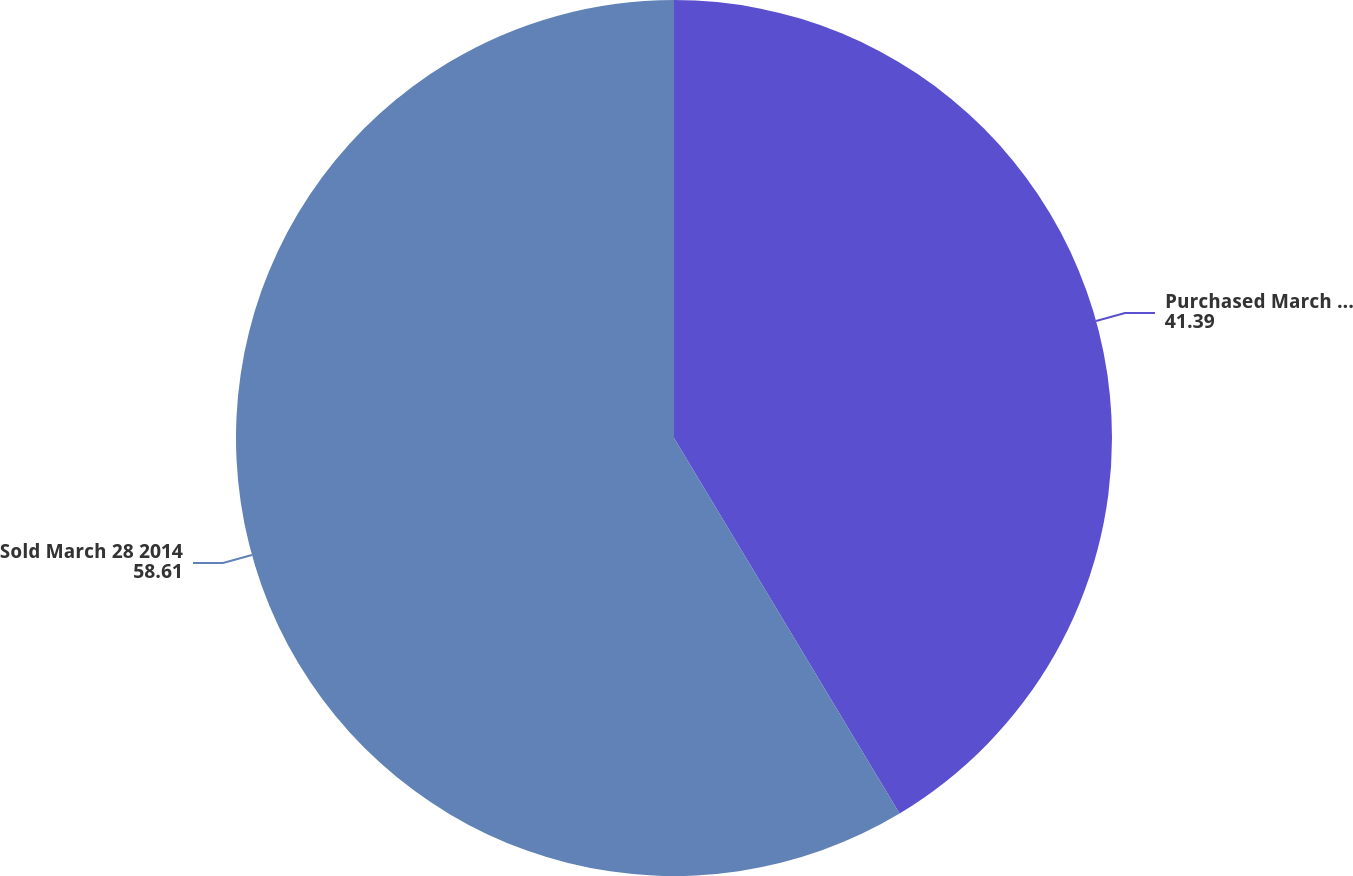Convert chart. <chart><loc_0><loc_0><loc_500><loc_500><pie_chart><fcel>Purchased March 28 2014<fcel>Sold March 28 2014<nl><fcel>41.39%<fcel>58.61%<nl></chart> 